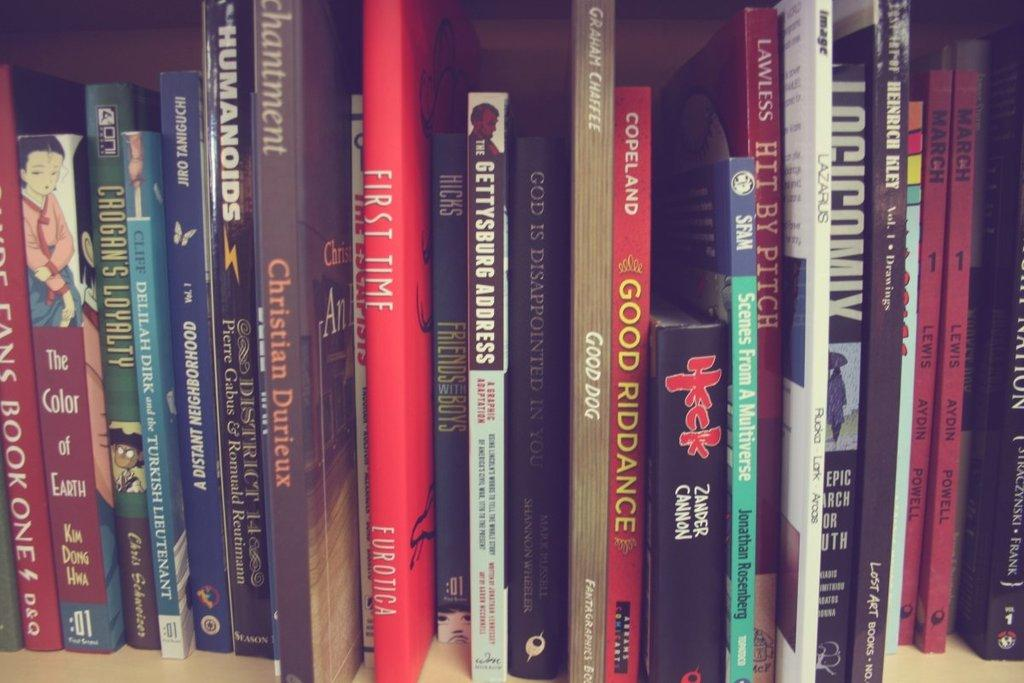<image>
Render a clear and concise summary of the photo. A red book with the title, "First Time" in on the shelf. 